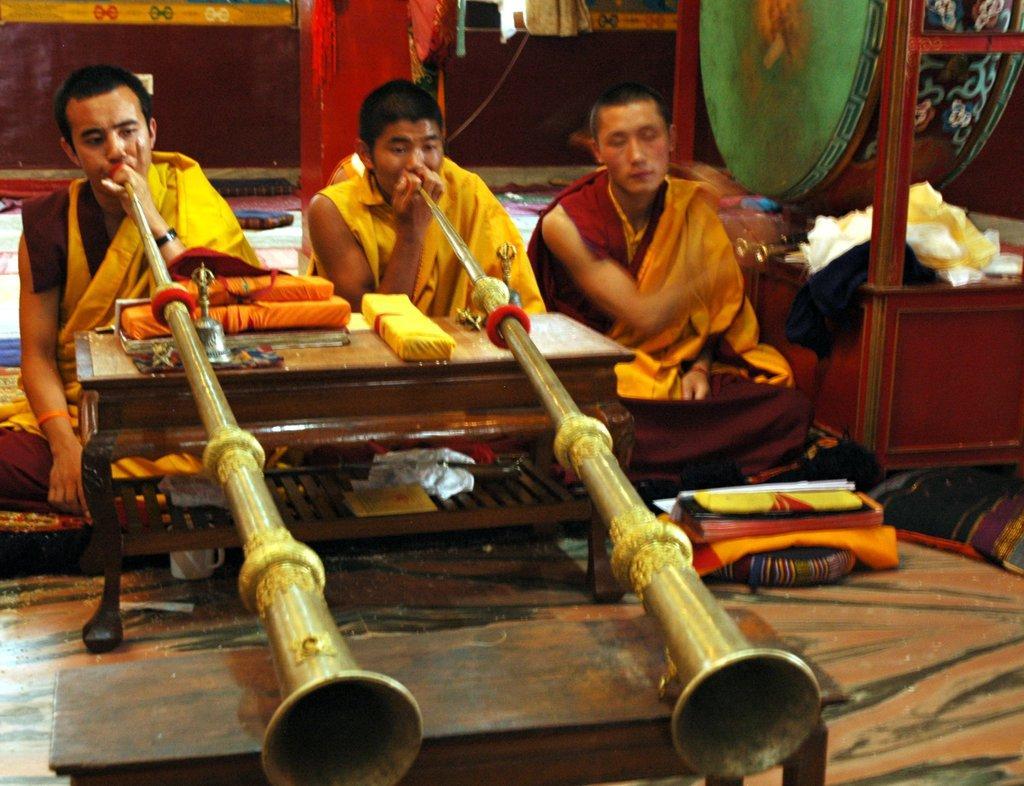Describe this image in one or two sentences. In this picture we can see there are three people sitting on the path and two people are holding some music instrument and in front of people, there is a table and on the table there are some objects. On the right side of the people there is a drum. Behind the people there is a wall. 